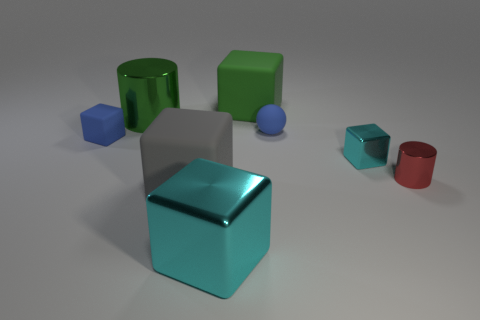There is a blue object on the right side of the small block on the left side of the large green cylinder; how big is it?
Your answer should be compact. Small. There is a blue matte object that is to the right of the tiny object to the left of the shiny object on the left side of the gray rubber cube; what shape is it?
Offer a terse response. Sphere. There is a big object that is made of the same material as the large cyan cube; what is its color?
Your answer should be compact. Green. The shiny cylinder on the left side of the large matte object right of the cyan object to the left of the green matte object is what color?
Provide a succinct answer. Green. What number of cylinders are either tiny objects or tiny cyan objects?
Provide a succinct answer. 1. There is a small ball that is the same color as the small matte cube; what is it made of?
Offer a terse response. Rubber. Is the color of the small metallic cube the same as the tiny shiny thing in front of the small metal cube?
Make the answer very short. No. What color is the small rubber sphere?
Keep it short and to the point. Blue. What number of objects are tiny metal objects or small red matte objects?
Provide a succinct answer. 2. There is a red thing that is the same size as the blue matte sphere; what is it made of?
Give a very brief answer. Metal. 